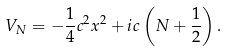Convert formula to latex. <formula><loc_0><loc_0><loc_500><loc_500>V _ { N } = - \frac { 1 } { 4 } c ^ { 2 } x ^ { 2 } + i c \left ( N + \frac { 1 } { 2 } \right ) .</formula> 